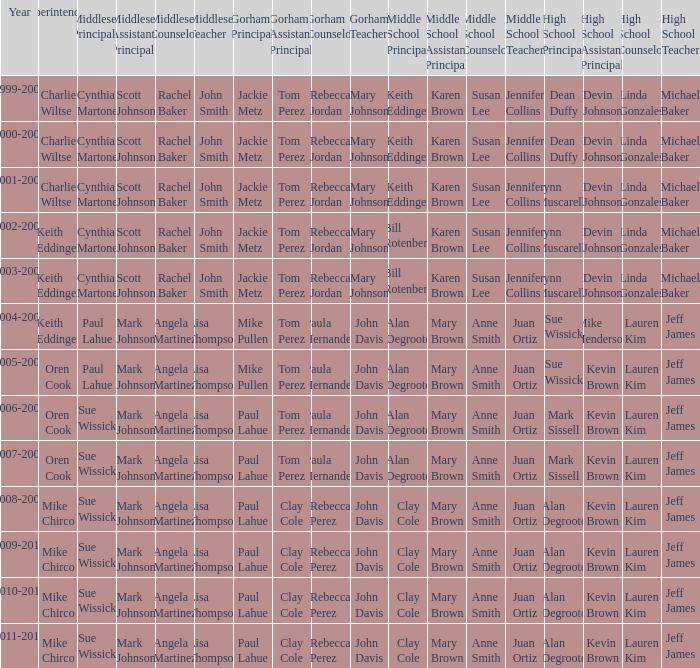Who were the middle school principal(s) in 2010-2011? Clay Cole. 